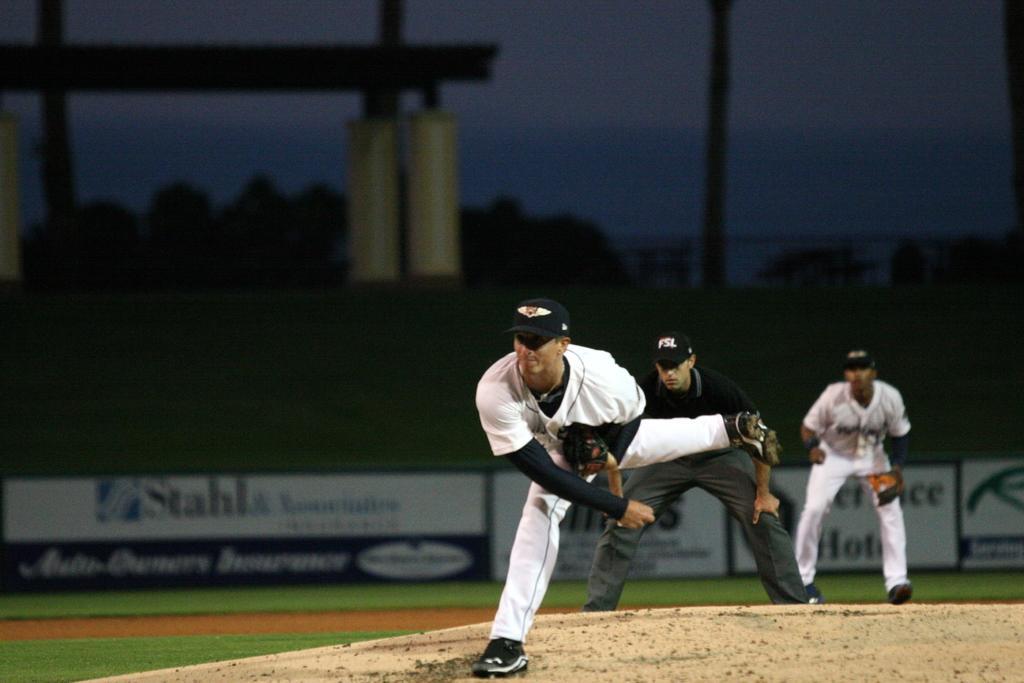Please provide a concise description of this image. In this image we can see men standing on the ground. In the background we can see trees, advertisement boards, poles and sky. 